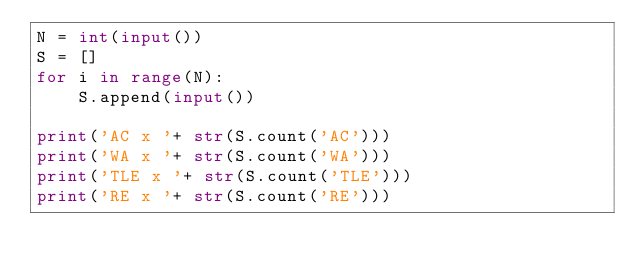Convert code to text. <code><loc_0><loc_0><loc_500><loc_500><_Python_>N = int(input())
S = []
for i in range(N):
    S.append(input())

print('AC x '+ str(S.count('AC')))
print('WA x '+ str(S.count('WA')))
print('TLE x '+ str(S.count('TLE')))
print('RE x '+ str(S.count('RE')))</code> 